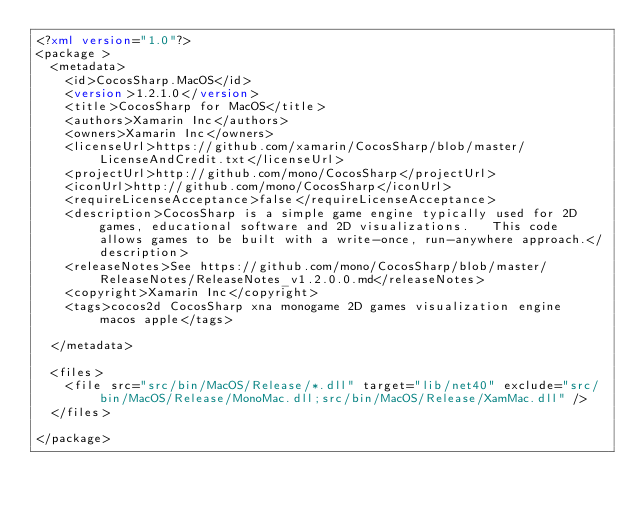<code> <loc_0><loc_0><loc_500><loc_500><_XML_><?xml version="1.0"?>
<package >
  <metadata>
    <id>CocosSharp.MacOS</id>
    <version>1.2.1.0</version>
    <title>CocosSharp for MacOS</title>
    <authors>Xamarin Inc</authors>
    <owners>Xamarin Inc</owners>
    <licenseUrl>https://github.com/xamarin/CocosSharp/blob/master/LicenseAndCredit.txt</licenseUrl>
    <projectUrl>http://github.com/mono/CocosSharp</projectUrl>
    <iconUrl>http://github.com/mono/CocosSharp</iconUrl>
    <requireLicenseAcceptance>false</requireLicenseAcceptance>
    <description>CocosSharp is a simple game engine typically used for 2D games, educational software and 2D visualizations.   This code allows games to be built with a write-once, run-anywhere approach.</description>
	<releaseNotes>See https://github.com/mono/CocosSharp/blob/master/ReleaseNotes/ReleaseNotes_v1.2.0.0.md</releaseNotes>
    <copyright>Xamarin Inc</copyright>
    <tags>cocos2d CocosSharp xna monogame 2D games visualization engine  macos apple</tags>

  </metadata>

  <files>
    <file src="src/bin/MacOS/Release/*.dll" target="lib/net40" exclude="src/bin/MacOS/Release/MonoMac.dll;src/bin/MacOS/Release/XamMac.dll" />
  </files>

</package></code> 